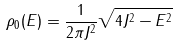<formula> <loc_0><loc_0><loc_500><loc_500>\rho _ { 0 } ( E ) = \frac { 1 } { 2 \pi J ^ { 2 } } \sqrt { 4 J ^ { 2 } - E ^ { 2 } }</formula> 